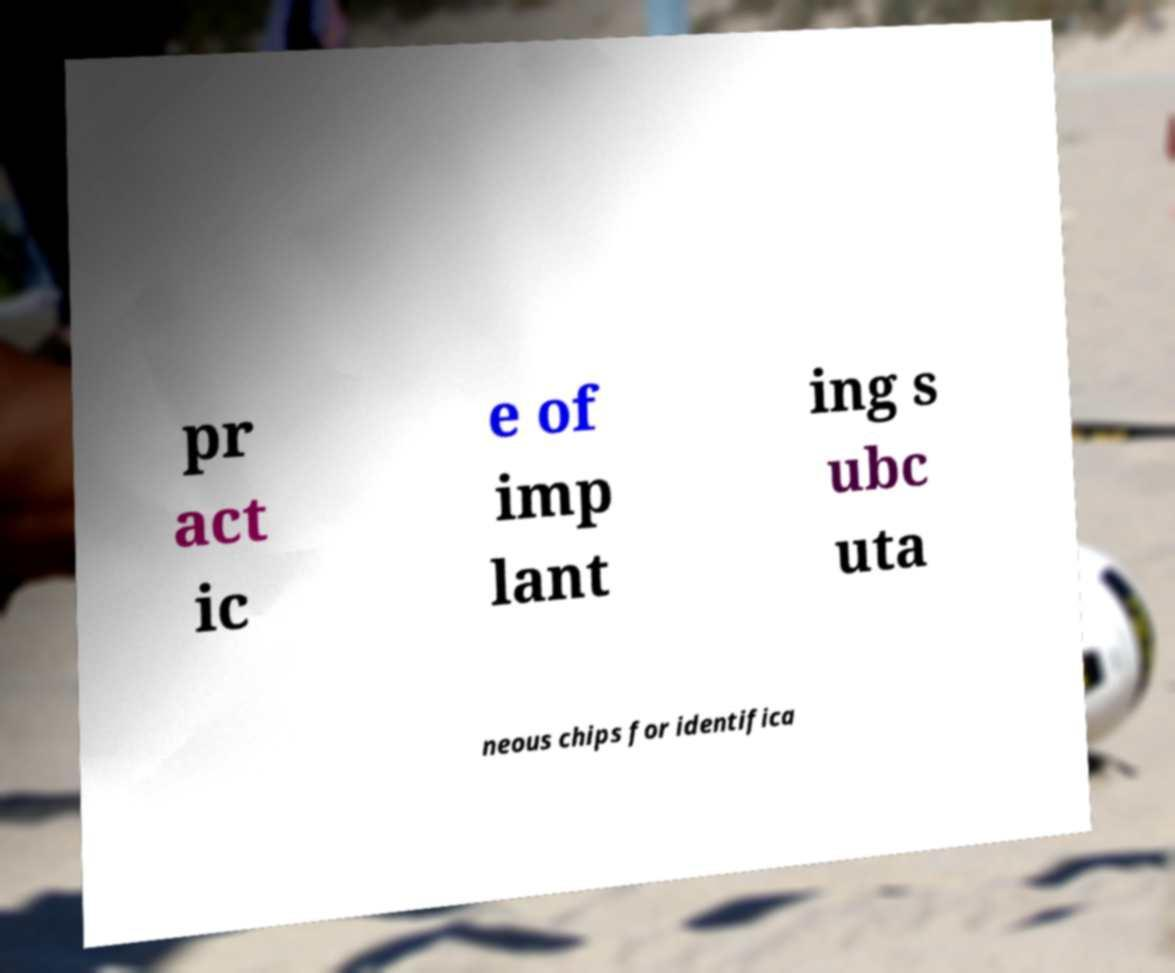For documentation purposes, I need the text within this image transcribed. Could you provide that? pr act ic e of imp lant ing s ubc uta neous chips for identifica 